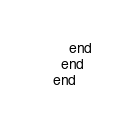<code> <loc_0><loc_0><loc_500><loc_500><_Ruby_>    end
  end
end
</code> 